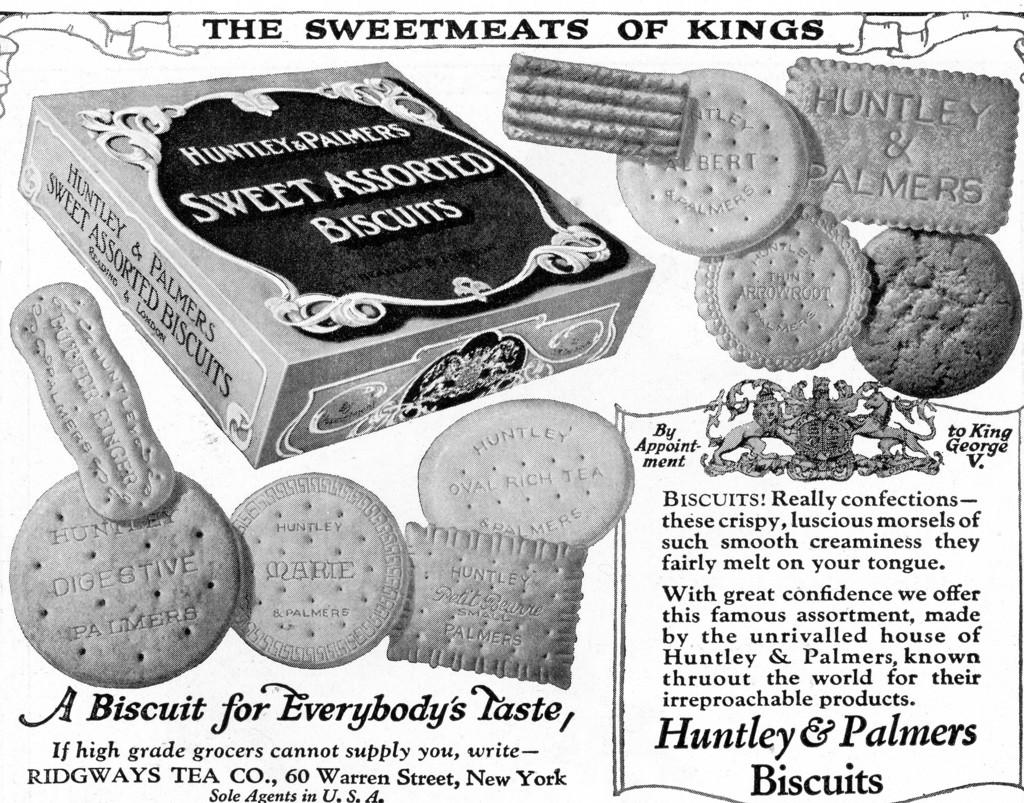What is the main subject of the poster in the image? The poster contains images of biscuits. What else is depicted on the poster besides the biscuits? The poster contains an image of a box. Is there any text on the poster? Yes, there is text on the poster. What type of wool is used to make the scene on the poster? There is no wool or scene present in the image; it features a poster with images of biscuits, a box, and text. 